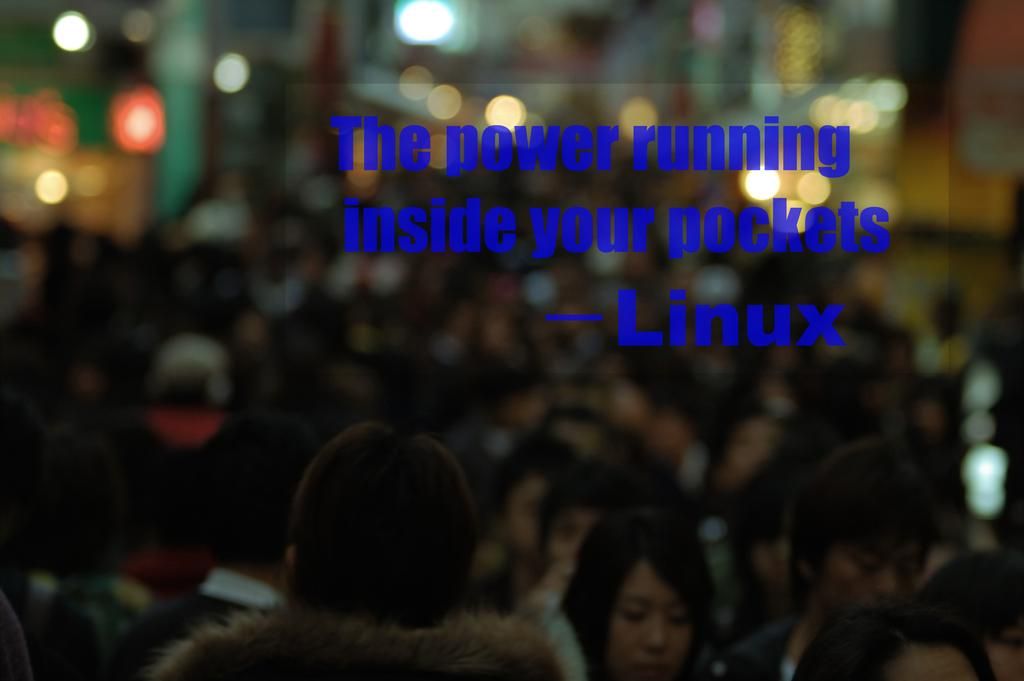How many people are in the image? There is a group of people in the image, but the exact number cannot be determined from the provided facts. What can be seen in the background of the image? There are lights visible in the background of the image. What type of information is present in the image? There is text or writing present in the image. How many arms are visible on the people in the image? The provided facts do not mention the number of arms visible on the people in the image, so it cannot be determined. Is there a bridge present in the image? There is no mention of a bridge in the provided facts, so it cannot be determined if one is present in the image. 